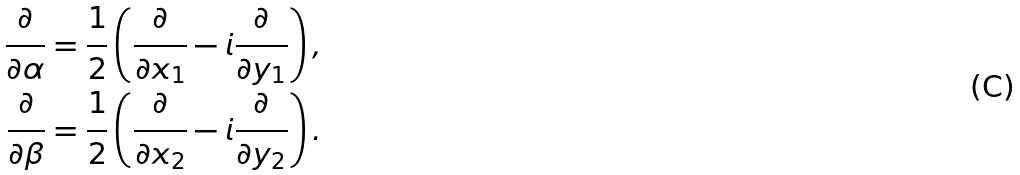Convert formula to latex. <formula><loc_0><loc_0><loc_500><loc_500>\frac { \partial } { \partial \alpha } = \frac { 1 } { 2 } \left ( \frac { \partial } { \partial x _ { 1 } } - i \frac { \partial } { \partial y _ { 1 } } \right ) , \\ \frac { \partial } { \partial \beta } = \frac { 1 } { 2 } \left ( \frac { \partial } { \partial x _ { 2 } } - i \frac { \partial } { \partial y _ { 2 } } \right ) .</formula> 